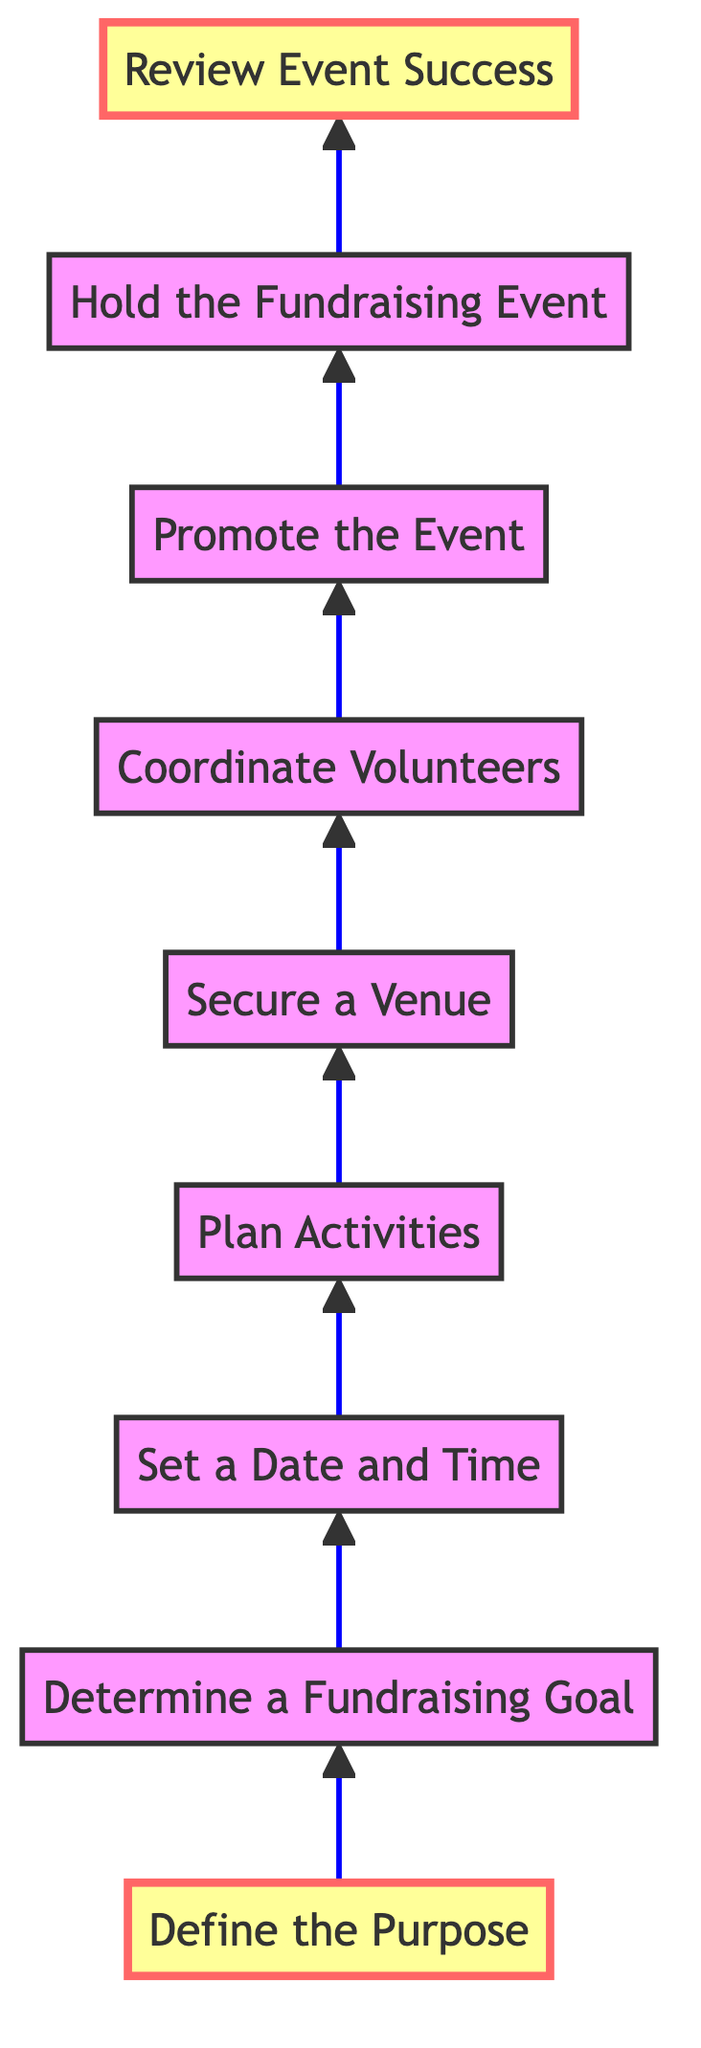What is the first step in the fundraising event planning process? The first step is defined at the bottom of the diagram, which shows "Define the Purpose" as the starting point for planning the fundraising event.
Answer: Define the Purpose How many total steps are involved in the process? By counting the nodes in the diagram from bottom to top, there are a total of nine steps involved in planning the fundraising event.
Answer: 9 What follows after determining a fundraising goal? The node directly above "Determine a Fundraising Goal" is "Set a Date and Time," indicating that this is the subsequent step in the process.
Answer: Set a Date and Time Which step comes before promoting the event? The step preceding "Promote the Event" is "Coordinate Volunteers," as seen when tracing the flow upwards.
Answer: Coordinate Volunteers What is the final step in the fundraising event planning process? The last step at the top of the diagram is "Review Event Success," indicating that this is the conclusion of the planning process.
Answer: Review Event Success What is the relationship between promoting the event and holding the event? The relationship is sequential; "Promote the Event" leads directly to "Hold the Fundraising Event," indicating that promotion must occur before the event is held.
Answer: Sequential If the purpose is identified, what is the second step to take? Once the purpose is defined, the next step is "Determine a Fundraising Goal," which connects directly to the first step in the flow.
Answer: Determine a Fundraising Goal How does securing a venue relate to planning activities? "Secure a Venue" depends on the outcomes of "Plan Activities," as selecting a venue requires knowledge of what activities will take place during the event.
Answer: Dependent What type of diagram is illustrated here? The diagram is a flow chart structured to depict a sequential process that progresses from bottom to up, outlining the steps involved in planning an event.
Answer: Flow chart 